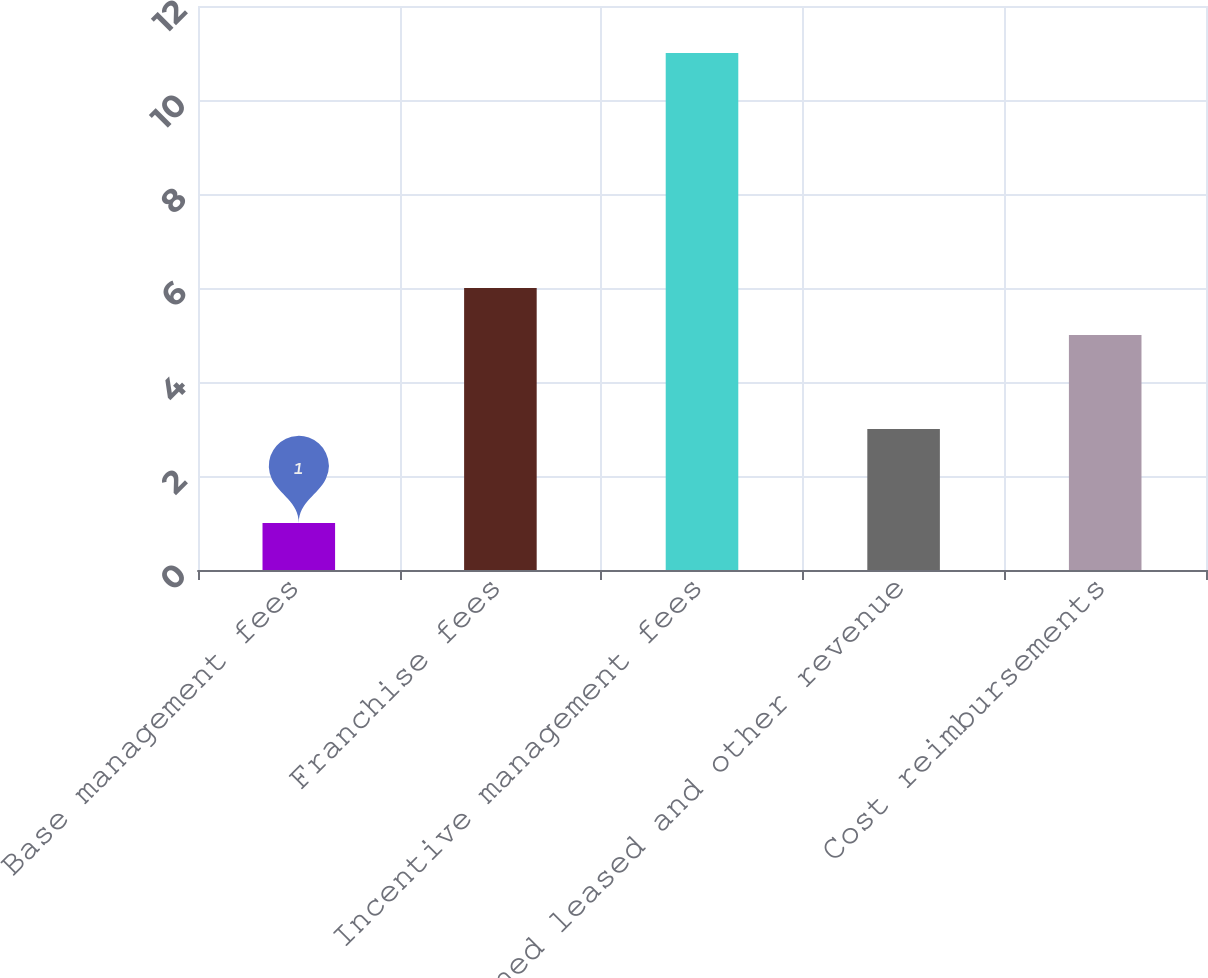Convert chart to OTSL. <chart><loc_0><loc_0><loc_500><loc_500><bar_chart><fcel>Base management fees<fcel>Franchise fees<fcel>Incentive management fees<fcel>Owned leased and other revenue<fcel>Cost reimbursements<nl><fcel>1<fcel>6<fcel>11<fcel>3<fcel>5<nl></chart> 